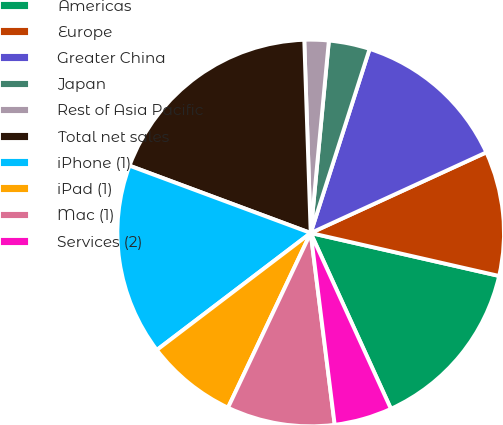Convert chart. <chart><loc_0><loc_0><loc_500><loc_500><pie_chart><fcel>Americas<fcel>Europe<fcel>Greater China<fcel>Japan<fcel>Rest of Asia Pacific<fcel>Total net sales<fcel>iPhone (1)<fcel>iPad (1)<fcel>Mac (1)<fcel>Services (2)<nl><fcel>14.62%<fcel>10.42%<fcel>13.22%<fcel>3.43%<fcel>2.03%<fcel>18.81%<fcel>16.01%<fcel>7.62%<fcel>9.02%<fcel>4.83%<nl></chart> 